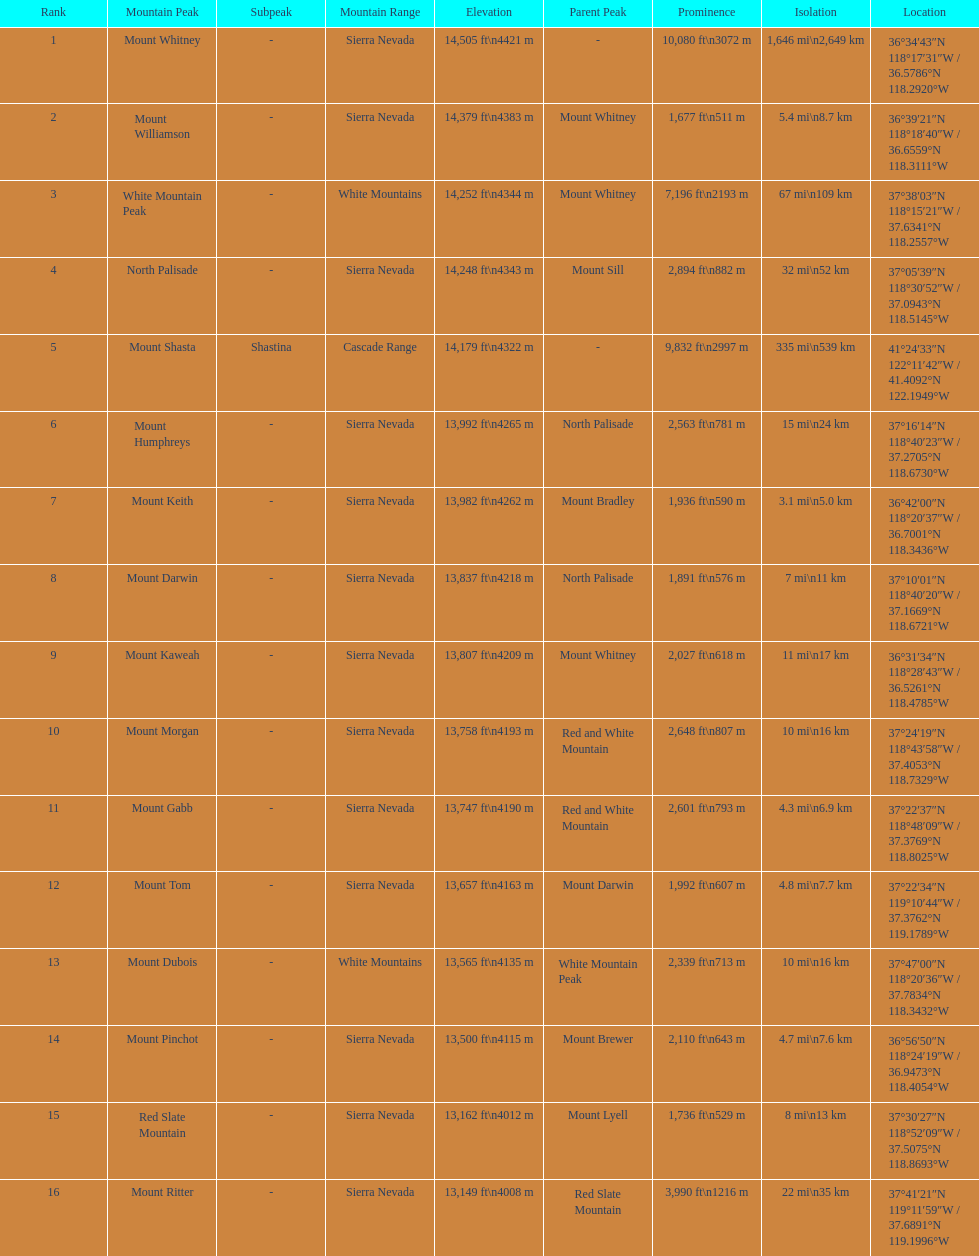Which is taller, mount humphreys or mount kaweah. Mount Humphreys. 